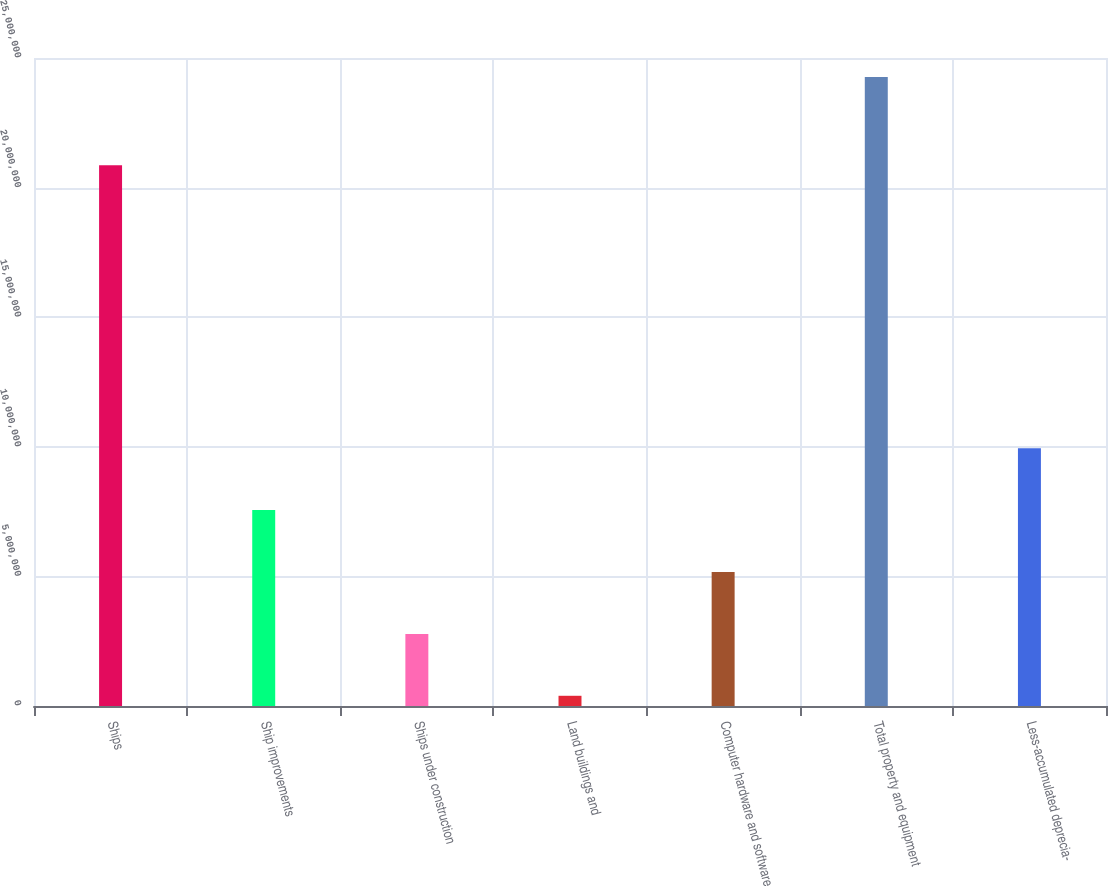Convert chart. <chart><loc_0><loc_0><loc_500><loc_500><bar_chart><fcel>Ships<fcel>Ship improvements<fcel>Ships under construction<fcel>Land buildings and<fcel>Computer hardware and software<fcel>Total property and equipment<fcel>Less-accumulated deprecia-<nl><fcel>2.08586e+07<fcel>7.55727e+06<fcel>2.78184e+06<fcel>394120<fcel>5.16956e+06<fcel>2.42713e+07<fcel>9.94499e+06<nl></chart> 